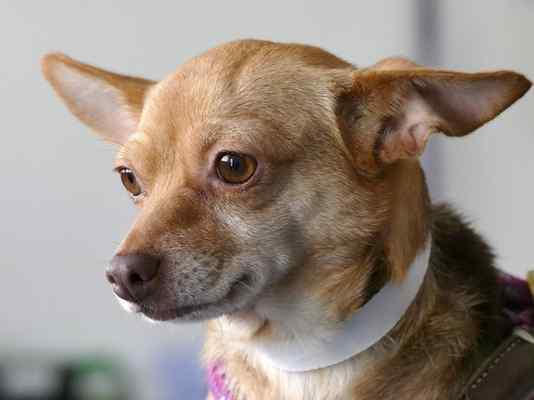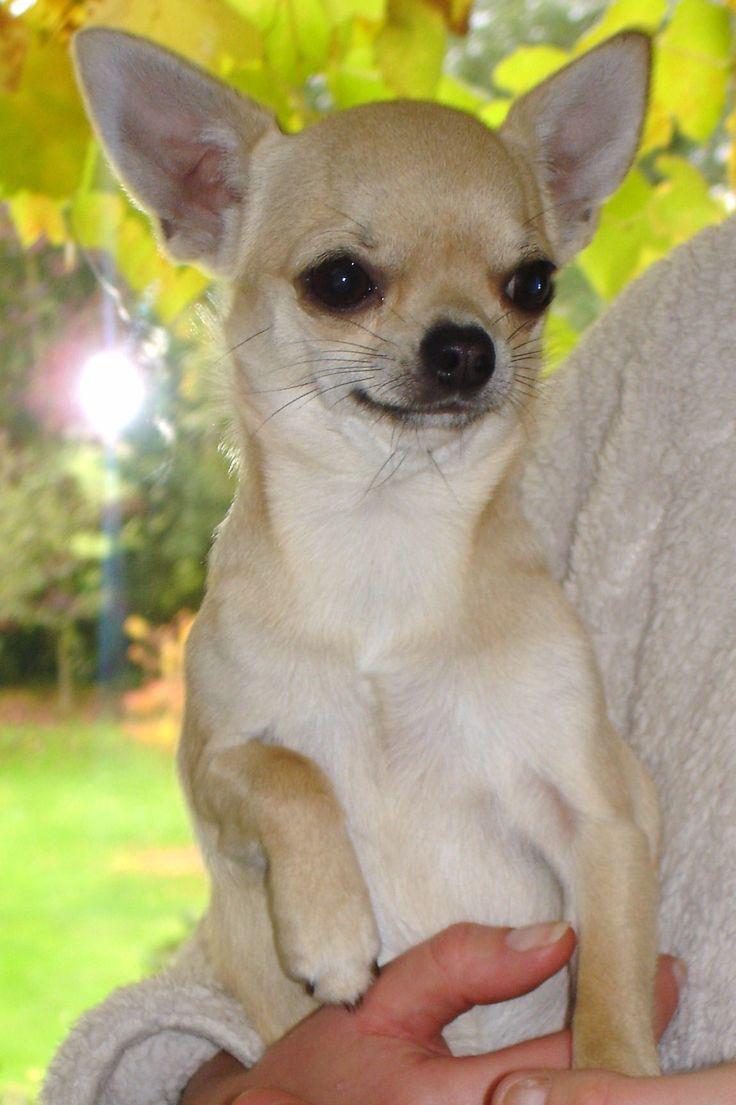The first image is the image on the left, the second image is the image on the right. Given the left and right images, does the statement "The dog in the image on the left has a white collar." hold true? Answer yes or no. Yes. The first image is the image on the left, the second image is the image on the right. For the images displayed, is the sentence "A chihuahua is sitting on a rug." factually correct? Answer yes or no. No. 